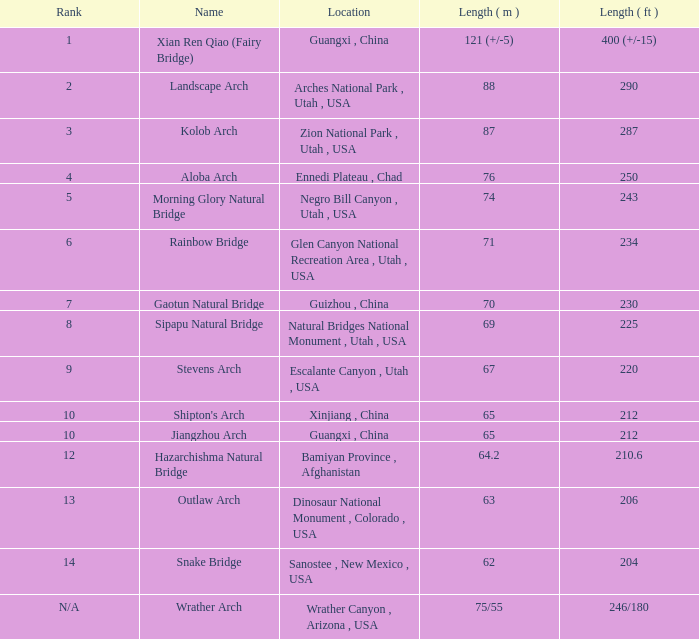How many feet long is the jiangzhou arch? 212.0. 